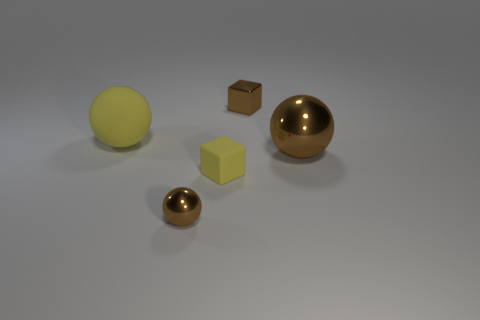Is there a large sphere that is behind the thing that is behind the large thing on the left side of the large metallic sphere?
Your answer should be very brief. No. How many other things are there of the same shape as the tiny yellow thing?
Provide a succinct answer. 1. The small shiny thing left of the small shiny thing behind the yellow sphere in front of the shiny cube is what color?
Provide a succinct answer. Brown. How many big metallic objects are there?
Give a very brief answer. 1. What number of tiny objects are either red matte things or metal objects?
Offer a terse response. 2. There is a yellow matte object that is the same size as the brown metal block; what is its shape?
Provide a succinct answer. Cube. Are there any other things that have the same size as the yellow rubber block?
Your answer should be compact. Yes. There is a tiny block behind the big ball to the left of the brown metallic block; what is its material?
Provide a short and direct response. Metal. Do the yellow matte block and the yellow sphere have the same size?
Give a very brief answer. No. What number of things are either tiny brown metal objects that are in front of the yellow sphere or tiny brown balls?
Your answer should be very brief. 1. 